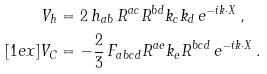Convert formula to latex. <formula><loc_0><loc_0><loc_500><loc_500>V _ { h } & = 2 \, h _ { a b } \, R ^ { a c } R ^ { b d } k _ { c } k _ { d } \, e ^ { - i k \cdot X } \, , \\ [ 1 e x ] V _ { C } & = - \frac { 2 } { 3 } \, F _ { a b c d } R ^ { a e } k _ { e } R ^ { b c d } \, e ^ { - i k \cdot X } \, .</formula> 